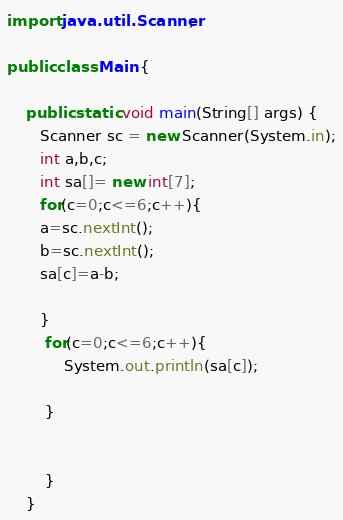<code> <loc_0><loc_0><loc_500><loc_500><_Java_>

import java.util.Scanner;

public class Main {
	
    public static void main(String[] args) {
	   Scanner sc = new Scanner(System.in);
	   int a,b,c;
	   int sa[]= new int[7];
	   for(c=0;c<=6;c++){
	   a=sc.nextInt();
	   b=sc.nextInt();
	   sa[c]=a-b;
	   
	   }
		for(c=0;c<=6;c++){
			System.out.println(sa[c]);			
			
		}


	    }
	}</code> 